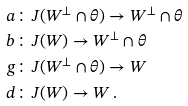Convert formula to latex. <formula><loc_0><loc_0><loc_500><loc_500>a & \colon J ( W ^ { \perp } \cap \theta ) \to W ^ { \perp } \cap \theta \\ b & \colon J ( W ) \to W ^ { \perp } \cap \theta \\ g & \colon J ( W ^ { \perp } \cap \theta ) \to W \\ d & \colon J ( W ) \to W \, .</formula> 